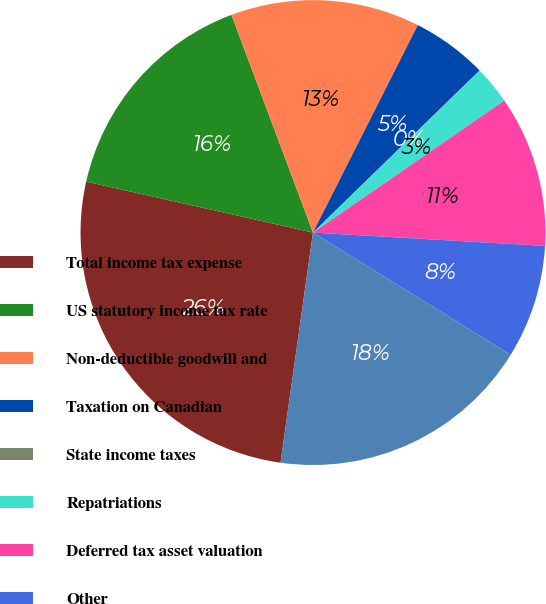Convert chart. <chart><loc_0><loc_0><loc_500><loc_500><pie_chart><fcel>Total income tax expense<fcel>US statutory income tax rate<fcel>Non-deductible goodwill and<fcel>Taxation on Canadian<fcel>State income taxes<fcel>Repatriations<fcel>Deferred tax asset valuation<fcel>Other<fcel>Effective income tax rate<nl><fcel>26.29%<fcel>15.78%<fcel>13.15%<fcel>5.27%<fcel>0.02%<fcel>2.65%<fcel>10.53%<fcel>7.9%<fcel>18.41%<nl></chart> 